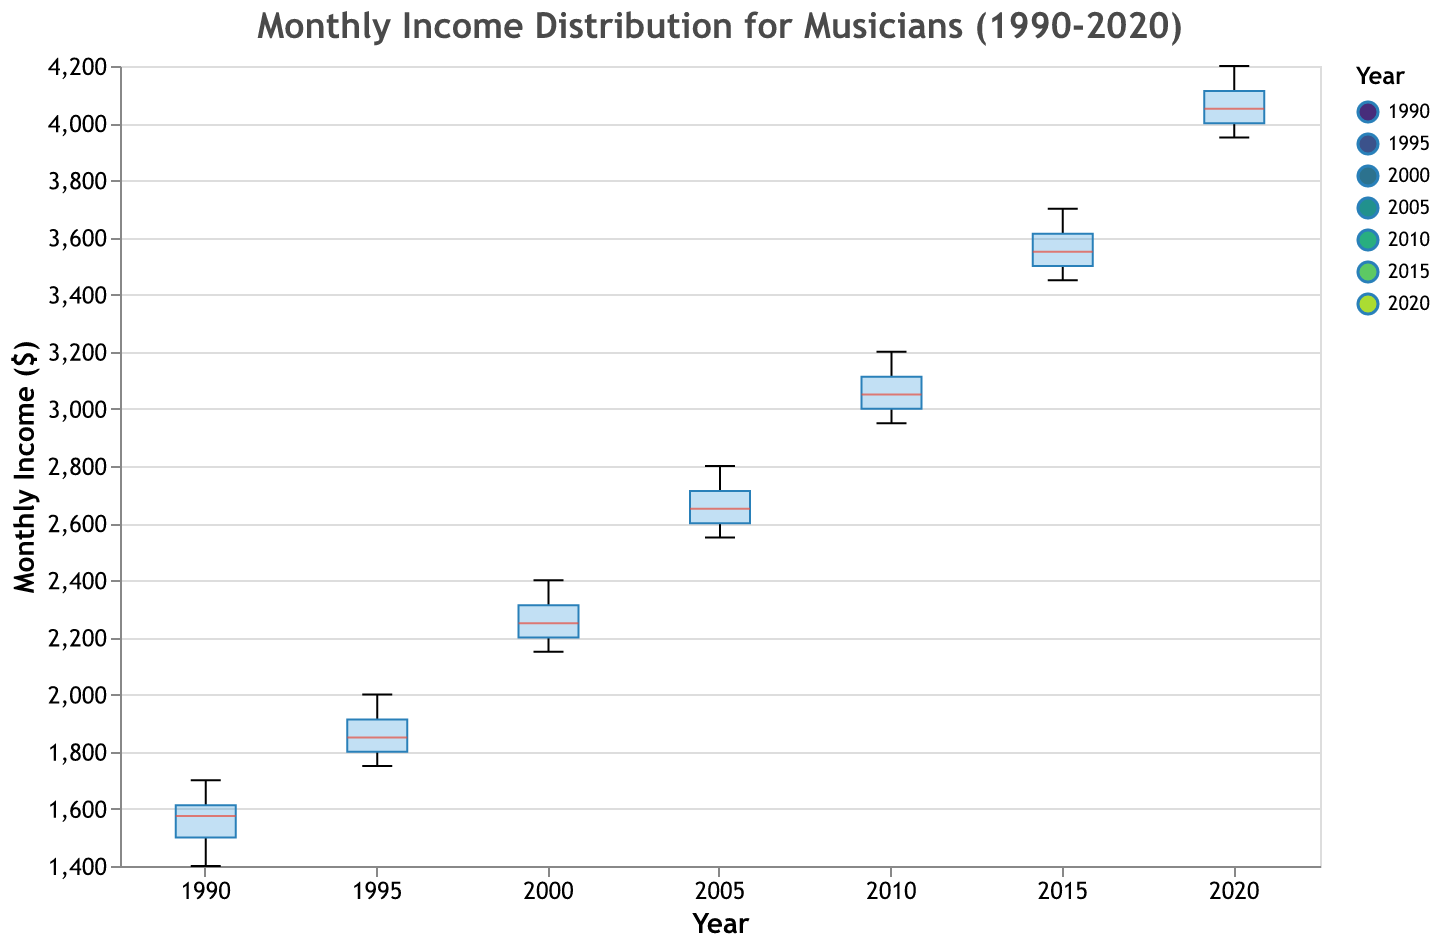What is the title of the plot? The title is usually displayed at the top of the plot. The title in this case reads "Monthly Income Distribution for Musicians (1990-2020)."
Answer: Monthly Income Distribution for Musicians (1990-2020) What does the y-axis represent? The y-axis label indicates what is being measured on this axis. In this plot, the y-axis represents "Monthly Income ($)."
Answer: Monthly Income ($) In which year was the median monthly income the highest? The notched box plot shows the median with a specific color for each year. By looking for the highest median within the designated color, we identify that the year 2020 has the highest median.
Answer: 2020 How does the range of monthly incomes in 1990 compare to that in 2020? The range is determined by the difference between the minimum and maximum values represented by the extent of the whiskers in the box plot. By visually assessing both years, it's clear that 2020 has a higher overall range of monthly incomes compared to 1990.
Answer: 2020 has a higher range What is the trend in the median monthly income of musicians from 1990 to 2020? By observing the medians of each year shown in the notched box plots, we can see a clear upward trend from 1990 to 2020, indicating that median monthly incomes have been increasing over time.
Answer: Increasing trend Which year has the widest interquartile range (IQR) of monthly income? The IQR is represented by the height of the box in each plot. By comparing the widths, the year 2020 appears to have the widest IQR, indicating a larger spread of the middle 50% of the data.
Answer: 2020 Are there any years where monthly incomes have outliers? Outliers in a notched box plot are typically represented as individual points beyond the whiskers. By identifying years with such points, we can confirm that all years contain outliers.
Answer: Yes, all years In which year did the monthly income for musicians appear most consistent? Consistency can be assessed by the narrowest box and whiskers, indicating lower variance. 1990 has more consistent monthly incomes compared to other years, judging by the relatively narrow IQR and whiskers.
Answer: 1990 Between 1995 and 2005, how did the median monthly income change for musicians? By comparing the median positions in the notched box plots for 1995 and 2005, it shows an increase from 1995 to 2005.
Answer: Increase What is the average maximum monthly income in the decade of the 2000s (2000-2009)? Since each box plot represents one year, identify the maximum in each box plot from the decade 2000-2009, then calculate their average. The maximum values are 2400, 2800, and 3200, respectively for the given years. So, the average is (2400 + 2800 + 3200) / 3 = 2800.
Answer: 2800 